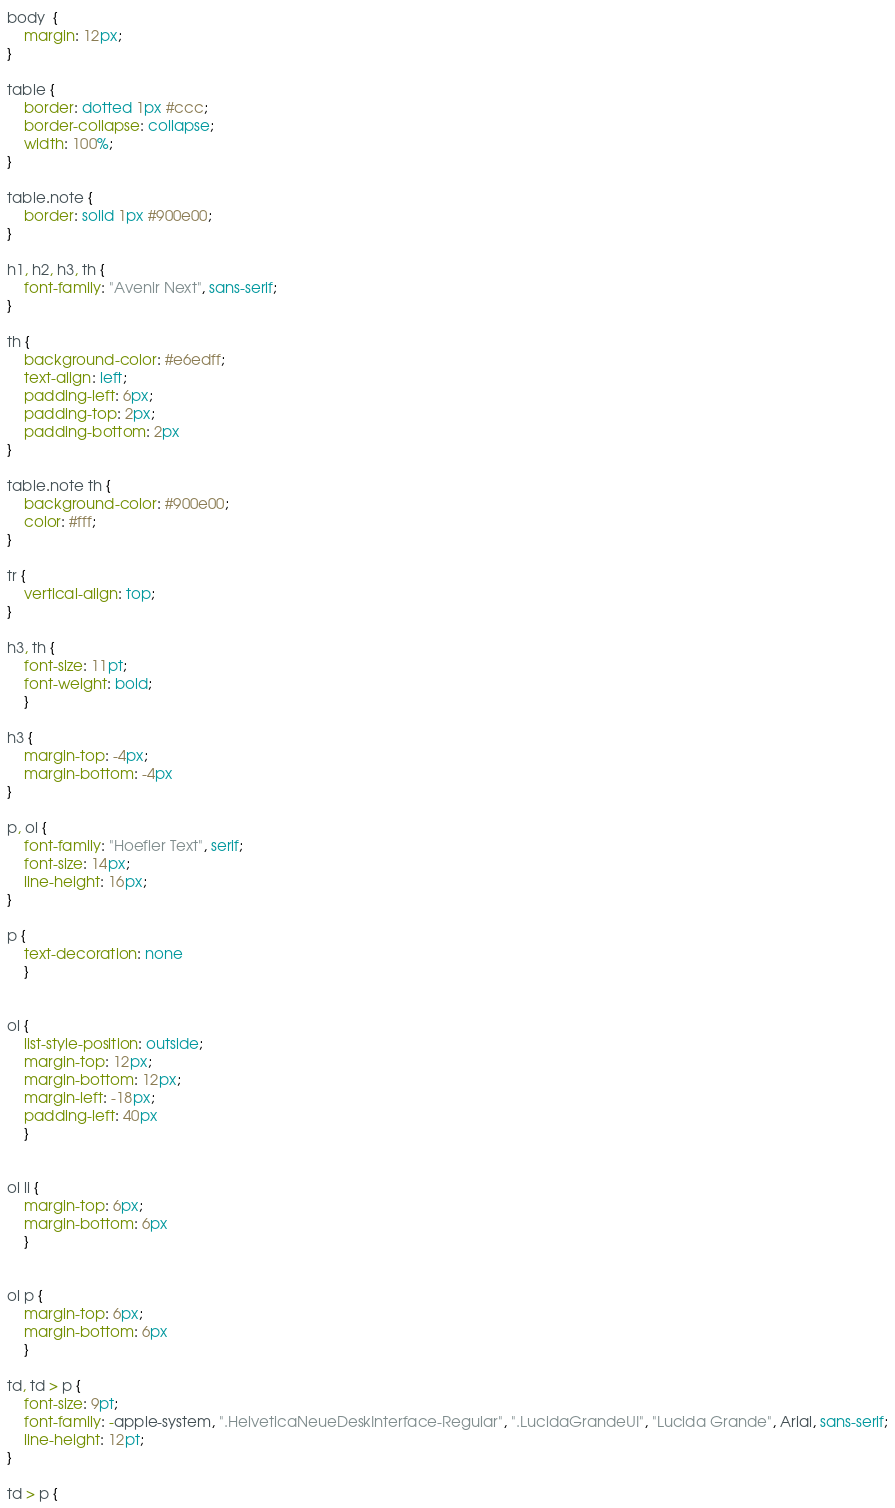Convert code to text. <code><loc_0><loc_0><loc_500><loc_500><_CSS_>body  {
	margin: 12px;
}

table {
	border: dotted 1px #ccc;
	border-collapse: collapse;
	width: 100%;
}

table.note {
	border: solid 1px #900e00;
}

h1, h2, h3, th {
	font-family: "Avenir Next", sans-serif;
}

th {
	background-color: #e6edff;
	text-align: left;
	padding-left: 6px;
	padding-top: 2px;
	padding-bottom: 2px
}

table.note th {
	background-color: #900e00;
	color: #fff;
}

tr {
	vertical-align: top;
}

h3, th {
	font-size: 11pt;
	font-weight: bold;
	}
	
h3 {
	margin-top: -4px;
	margin-bottom: -4px
}

p, ol {
	font-family: "Hoefler Text", serif;
	font-size: 14px;
	line-height: 16px;
}

p {
	text-decoration: none
	}


ol {
	list-style-position: outside;
	margin-top: 12px;
	margin-bottom: 12px;
	margin-left: -18px;
	padding-left: 40px
	}


ol li {
	margin-top: 6px;
	margin-bottom: 6px
	}


ol p {
	margin-top: 6px;
	margin-bottom: 6px
	}

td, td > p {
	font-size: 9pt;
	font-family: -apple-system, ".HelveticaNeueDeskInterface-Regular", ".LucidaGrandeUI", "Lucida Grande", Arial, sans-serif;
	line-height: 12pt;
}

td > p {</code> 